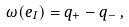Convert formula to latex. <formula><loc_0><loc_0><loc_500><loc_500>\omega ( e _ { I } ) = q _ { + } - q _ { - } \, ,</formula> 